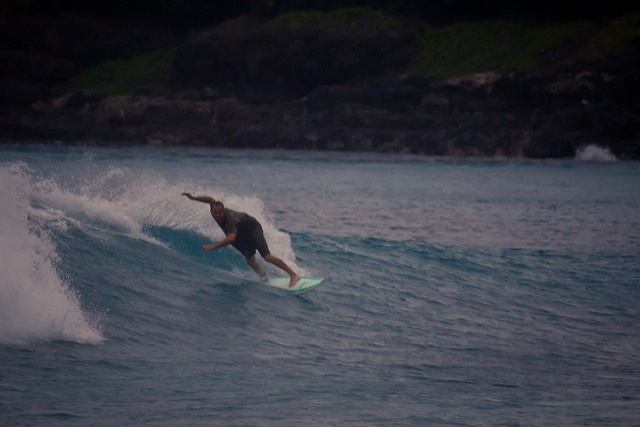Describe the objects in this image and their specific colors. I can see people in black, gray, and maroon tones and surfboard in black, darkgray, gray, and teal tones in this image. 